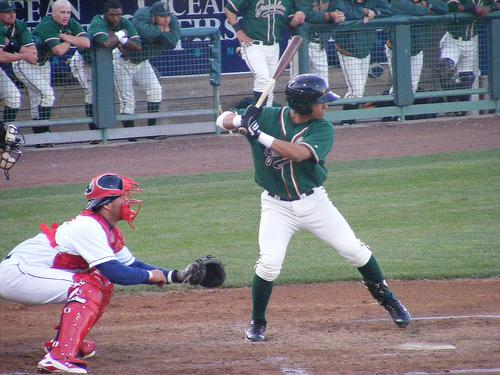Question: what are the men doing?
Choices:
A. Drinking beer.
B. Fighting.
C. Playing baseball.
D. Smiling.
Answer with the letter. Answer: C Question: what are the men wearing on their heads?
Choices:
A. Baseball caps.
B. Beanies.
C. Nothing.
D. Helmets.
Answer with the letter. Answer: D Question: what color are the men's pants?
Choices:
A. Blue.
B. Brown.
C. White.
D. Black.
Answer with the letter. Answer: C Question: how is the weather?
Choices:
A. Sunny.
B. Overcast.
C. Cloudy.
D. Cold.
Answer with the letter. Answer: B Question: where is this picture taken?
Choices:
A. A baseball field.
B. Outside.
C. In a dugout.
D. On bleachers.
Answer with the letter. Answer: A 